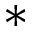<formula> <loc_0><loc_0><loc_500><loc_500>*</formula> 